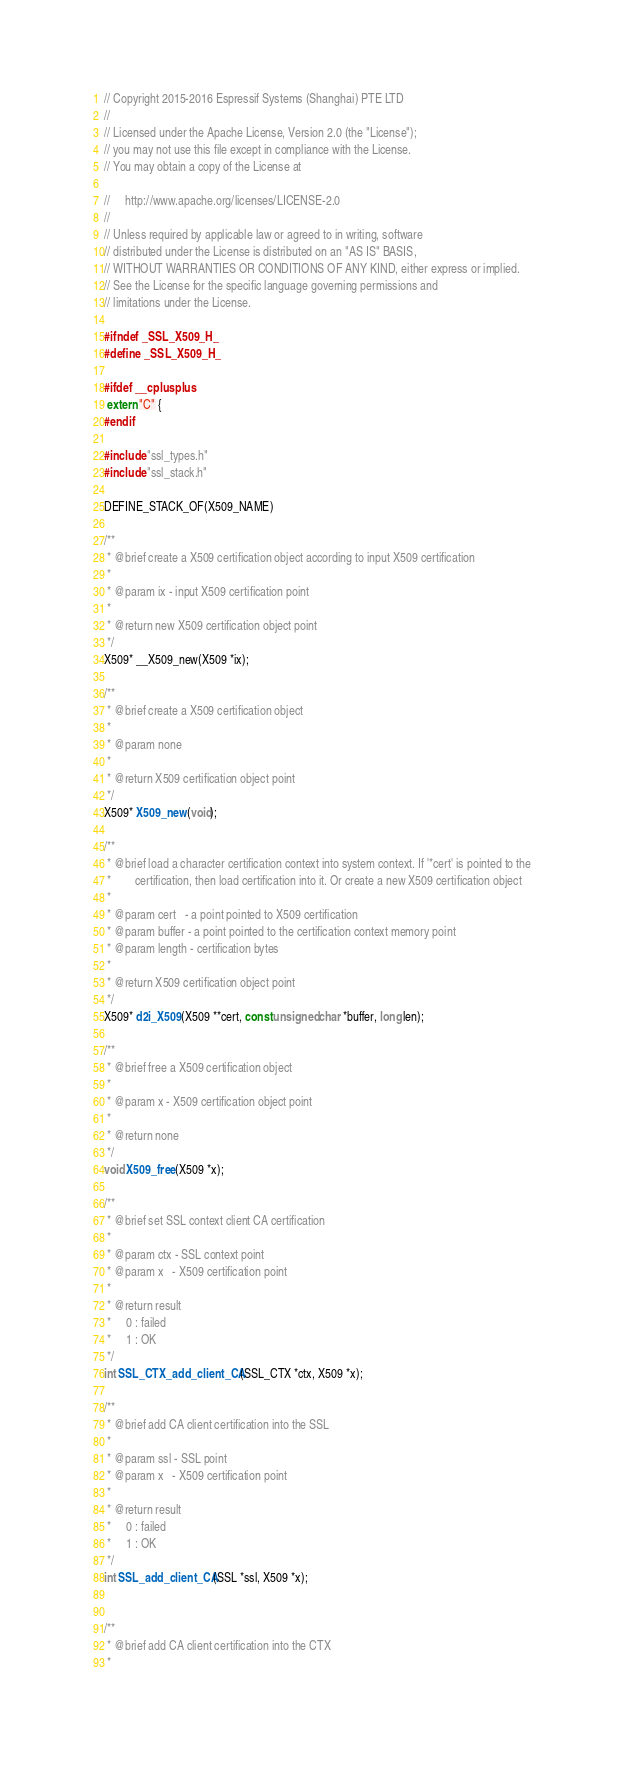<code> <loc_0><loc_0><loc_500><loc_500><_C_>// Copyright 2015-2016 Espressif Systems (Shanghai) PTE LTD
//
// Licensed under the Apache License, Version 2.0 (the "License");
// you may not use this file except in compliance with the License.
// You may obtain a copy of the License at

//     http://www.apache.org/licenses/LICENSE-2.0
//
// Unless required by applicable law or agreed to in writing, software
// distributed under the License is distributed on an "AS IS" BASIS,
// WITHOUT WARRANTIES OR CONDITIONS OF ANY KIND, either express or implied.
// See the License for the specific language governing permissions and
// limitations under the License.

#ifndef _SSL_X509_H_
#define _SSL_X509_H_

#ifdef __cplusplus
 extern "C" {
#endif

#include "ssl_types.h"
#include "ssl_stack.h"

DEFINE_STACK_OF(X509_NAME)

/**
 * @brief create a X509 certification object according to input X509 certification
 *
 * @param ix - input X509 certification point
 *
 * @return new X509 certification object point
 */
X509* __X509_new(X509 *ix);

/**
 * @brief create a X509 certification object
 *
 * @param none
 *
 * @return X509 certification object point
 */
X509* X509_new(void);

/**
 * @brief load a character certification context into system context. If '*cert' is pointed to the
 *        certification, then load certification into it. Or create a new X509 certification object
 *
 * @param cert   - a point pointed to X509 certification
 * @param buffer - a point pointed to the certification context memory point
 * @param length - certification bytes
 *
 * @return X509 certification object point
 */
X509* d2i_X509(X509 **cert, const unsigned char *buffer, long len);

/**
 * @brief free a X509 certification object
 *
 * @param x - X509 certification object point
 *
 * @return none
 */
void X509_free(X509 *x);

/**
 * @brief set SSL context client CA certification
 *
 * @param ctx - SSL context point
 * @param x   - X509 certification point
 *
 * @return result
 *     0 : failed
 *     1 : OK
 */
int SSL_CTX_add_client_CA(SSL_CTX *ctx, X509 *x);

/**
 * @brief add CA client certification into the SSL
 *
 * @param ssl - SSL point
 * @param x   - X509 certification point
 *
 * @return result
 *     0 : failed
 *     1 : OK
 */
int SSL_add_client_CA(SSL *ssl, X509 *x);


/**
 * @brief add CA client certification into the CTX
 *</code> 